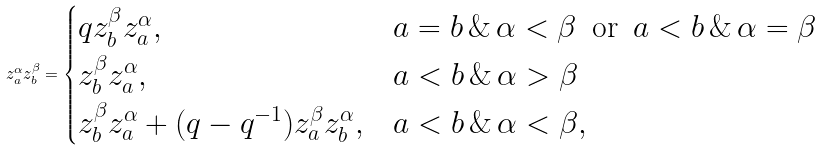Convert formula to latex. <formula><loc_0><loc_0><loc_500><loc_500>z _ { a } ^ { \alpha } z _ { b } ^ { \beta } = \begin{cases} q z _ { b } ^ { \beta } z _ { a } ^ { \alpha } , & a = b \, \& \, \alpha < \beta \, \text {\ or\ } \, a < b \, \& \, \alpha = \beta \\ z _ { b } ^ { \beta } z _ { a } ^ { \alpha } , & a < b \, \& \, \alpha > \beta \\ z _ { b } ^ { \beta } z _ { a } ^ { \alpha } + ( q - q ^ { - 1 } ) z _ { a } ^ { \beta } z _ { b } ^ { \alpha } , & a < b \, \& \, \alpha < \beta , \end{cases}</formula> 